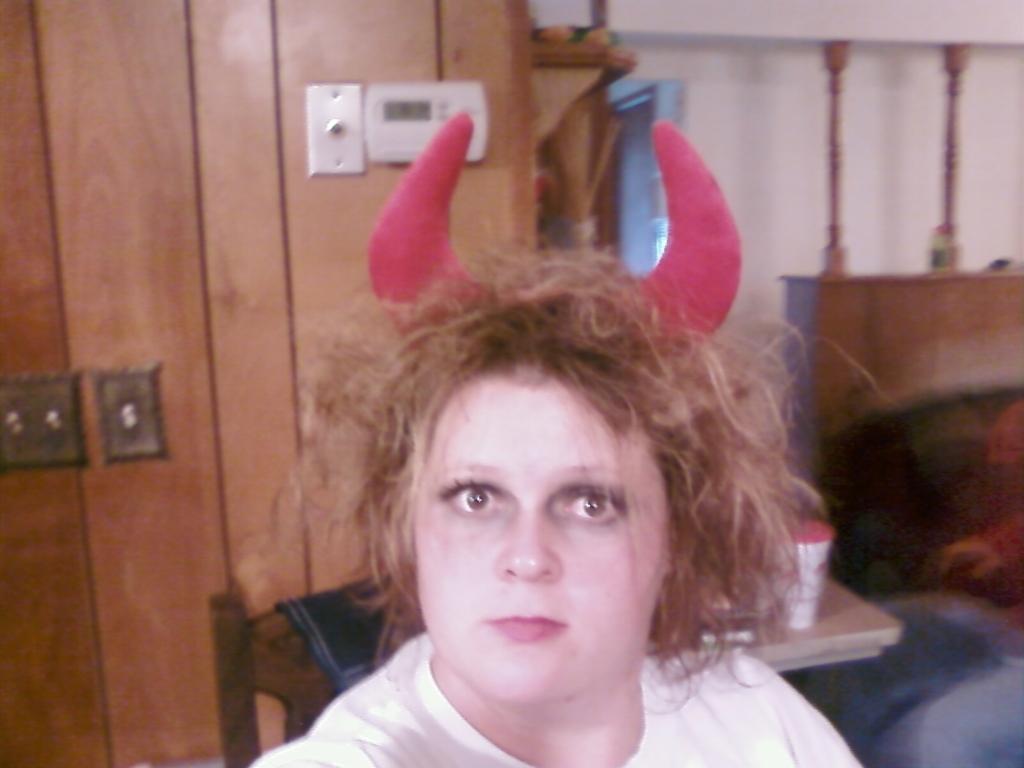Describe this image in one or two sentences. In this image we can see a woman wearing horns. On the backside we can see a wall, a napkin on a chair, a person sitting and a container on a table. 